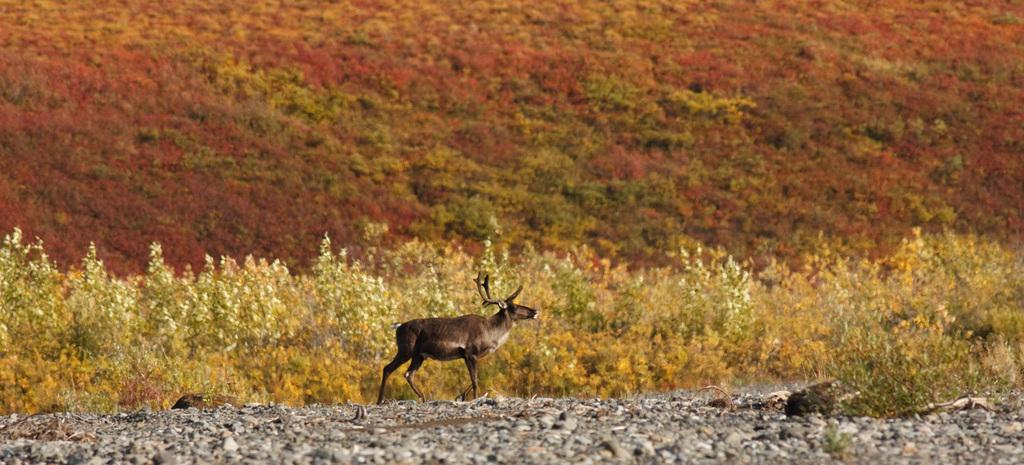What type of animal can be seen in the image? There is an animal in the image, but its specific type cannot be determined from the provided facts. Where is the animal located in the image? The animal is on the ground in the image. What else can be seen on the ground in the image? Stones are visible in the image. What type of vegetation is present in the image? There are plants in the image. How many questions are being asked in the image? There is no indication of any questions being asked in the image. Can you see a plane in the image? There is no plane present in the image. 